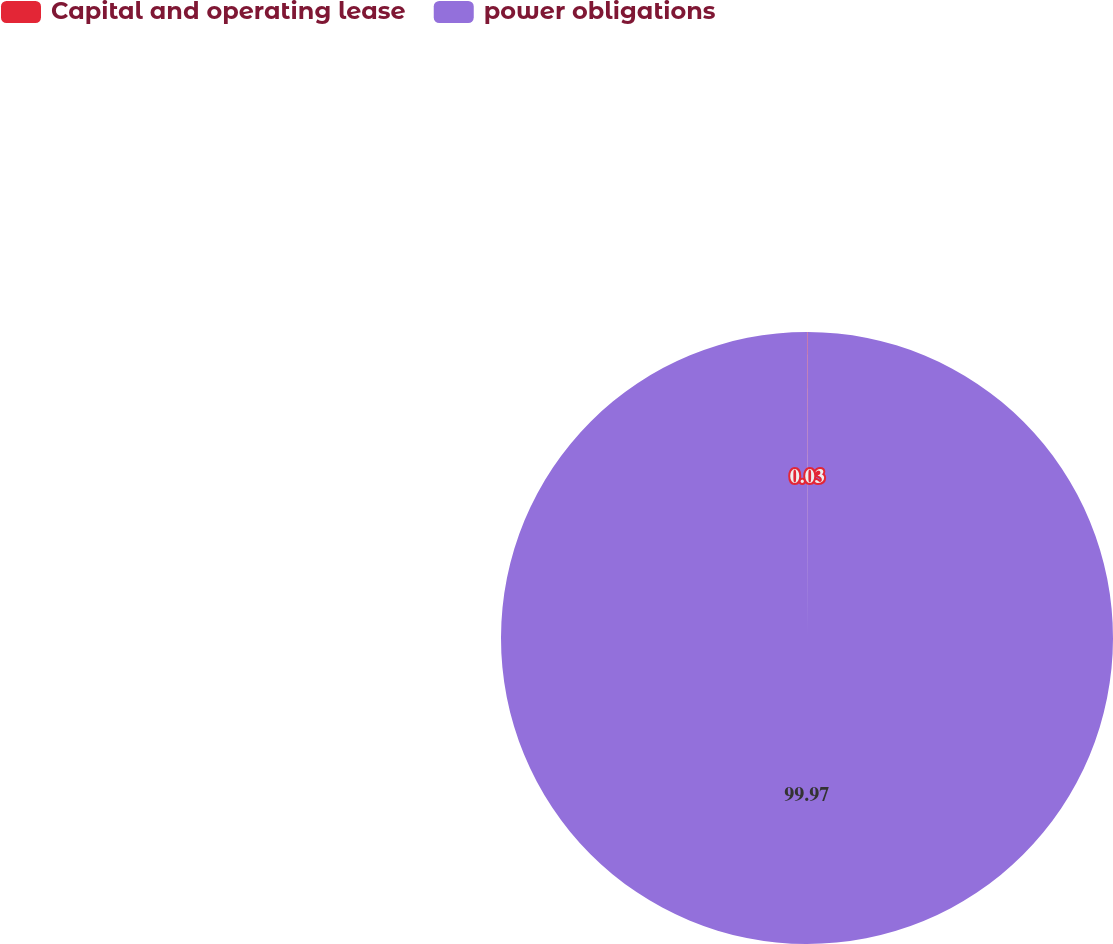Convert chart. <chart><loc_0><loc_0><loc_500><loc_500><pie_chart><fcel>Capital and operating lease<fcel>power obligations<nl><fcel>0.03%<fcel>99.97%<nl></chart> 